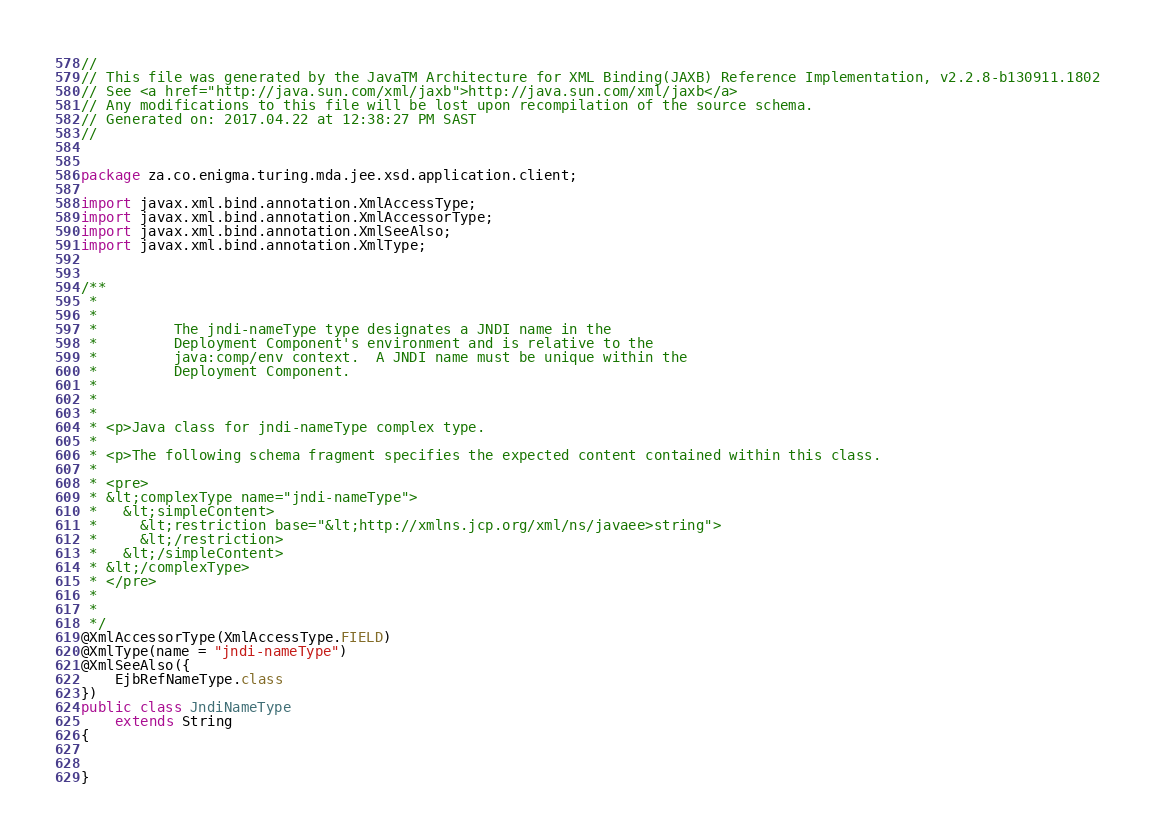<code> <loc_0><loc_0><loc_500><loc_500><_Java_>//
// This file was generated by the JavaTM Architecture for XML Binding(JAXB) Reference Implementation, v2.2.8-b130911.1802 
// See <a href="http://java.sun.com/xml/jaxb">http://java.sun.com/xml/jaxb</a> 
// Any modifications to this file will be lost upon recompilation of the source schema. 
// Generated on: 2017.04.22 at 12:38:27 PM SAST 
//


package za.co.enigma.turing.mda.jee.xsd.application.client;

import javax.xml.bind.annotation.XmlAccessType;
import javax.xml.bind.annotation.XmlAccessorType;
import javax.xml.bind.annotation.XmlSeeAlso;
import javax.xml.bind.annotation.XmlType;


/**
 * 
 * 
 *         The jndi-nameType type designates a JNDI name in the
 *         Deployment Component's environment and is relative to the
 *         java:comp/env context.  A JNDI name must be unique within the
 *         Deployment Component.
 *         
 *       
 * 
 * <p>Java class for jndi-nameType complex type.
 * 
 * <p>The following schema fragment specifies the expected content contained within this class.
 * 
 * <pre>
 * &lt;complexType name="jndi-nameType">
 *   &lt;simpleContent>
 *     &lt;restriction base="&lt;http://xmlns.jcp.org/xml/ns/javaee>string">
 *     &lt;/restriction>
 *   &lt;/simpleContent>
 * &lt;/complexType>
 * </pre>
 * 
 * 
 */
@XmlAccessorType(XmlAccessType.FIELD)
@XmlType(name = "jndi-nameType")
@XmlSeeAlso({
    EjbRefNameType.class
})
public class JndiNameType
    extends String
{


}
</code> 